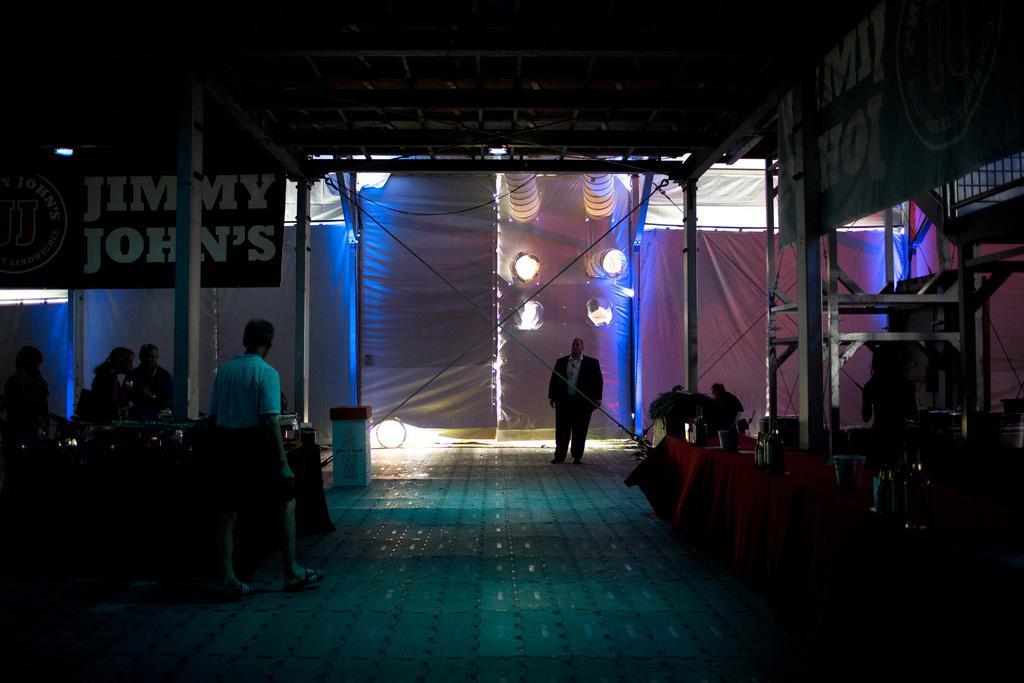Can you describe this image briefly? In this image there are group of persons standing. In the background there is a tent which is white in colour and on the left side there is a board with some text on it and there are poles. On the right side there is a cloth which is red in colour and there are objects on the clock. In the center there is a man standing and on the left side there is a man walking. On the right side there is a banner with some text written on it. 